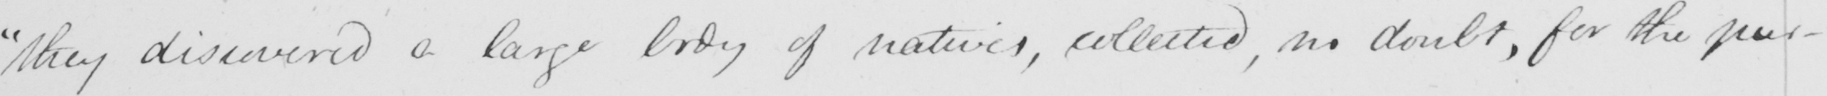Transcribe the text shown in this historical manuscript line. " they discovered a large body of natives , collected , no doubt , for the pur- 